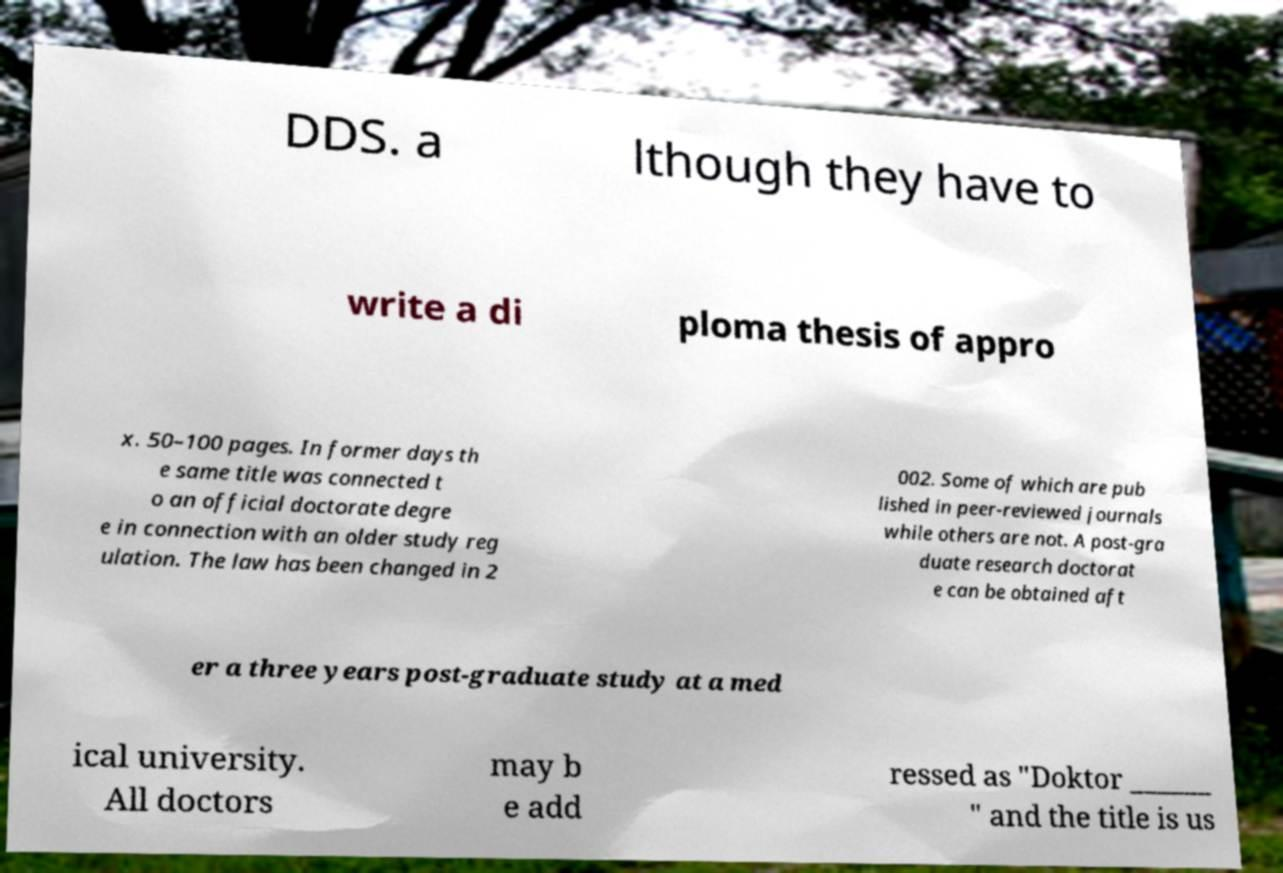For documentation purposes, I need the text within this image transcribed. Could you provide that? DDS. a lthough they have to write a di ploma thesis of appro x. 50–100 pages. In former days th e same title was connected t o an official doctorate degre e in connection with an older study reg ulation. The law has been changed in 2 002. Some of which are pub lished in peer-reviewed journals while others are not. A post-gra duate research doctorat e can be obtained aft er a three years post-graduate study at a med ical university. All doctors may b e add ressed as "Doktor ______ " and the title is us 